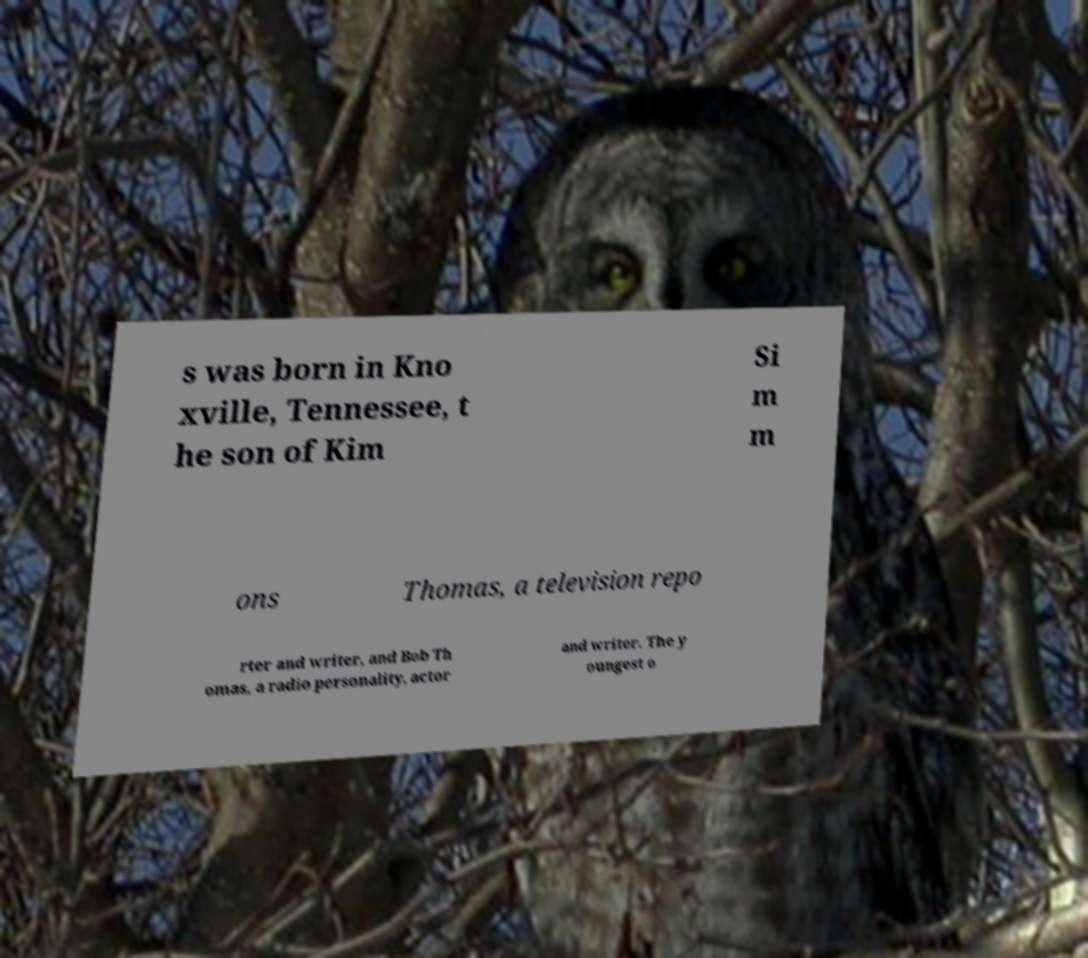For documentation purposes, I need the text within this image transcribed. Could you provide that? s was born in Kno xville, Tennessee, t he son of Kim Si m m ons Thomas, a television repo rter and writer, and Bob Th omas, a radio personality, actor and writer. The y oungest o 